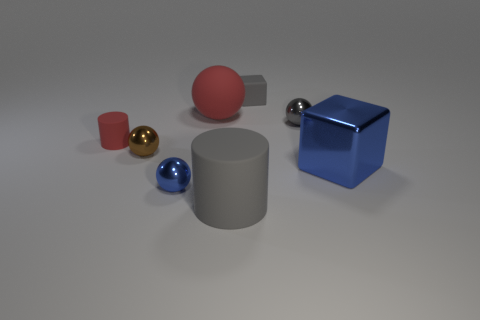There is a big rubber cylinder; is its color the same as the tiny sphere that is on the right side of the small gray matte block?
Your response must be concise. Yes. The ball that is the same color as the small matte cylinder is what size?
Make the answer very short. Large. What number of blue objects are either tiny metallic balls or large matte cylinders?
Ensure brevity in your answer.  1. Do the rubber thing in front of the small rubber cylinder and the small rubber block have the same color?
Your answer should be compact. Yes. Do the small cylinder and the tiny brown ball have the same material?
Provide a short and direct response. No. Are there the same number of brown balls on the right side of the big gray matte object and big matte objects in front of the big matte sphere?
Your response must be concise. No. There is a tiny brown object that is the same shape as the small blue thing; what is its material?
Provide a succinct answer. Metal. What is the shape of the tiny rubber object that is behind the matte cylinder that is on the left side of the blue shiny thing left of the small gray metallic object?
Give a very brief answer. Cube. Is the number of red spheres that are to the right of the large cube greater than the number of tiny gray spheres?
Your answer should be very brief. No. Is the shape of the tiny thing that is behind the rubber ball the same as  the large blue object?
Your answer should be very brief. Yes. 